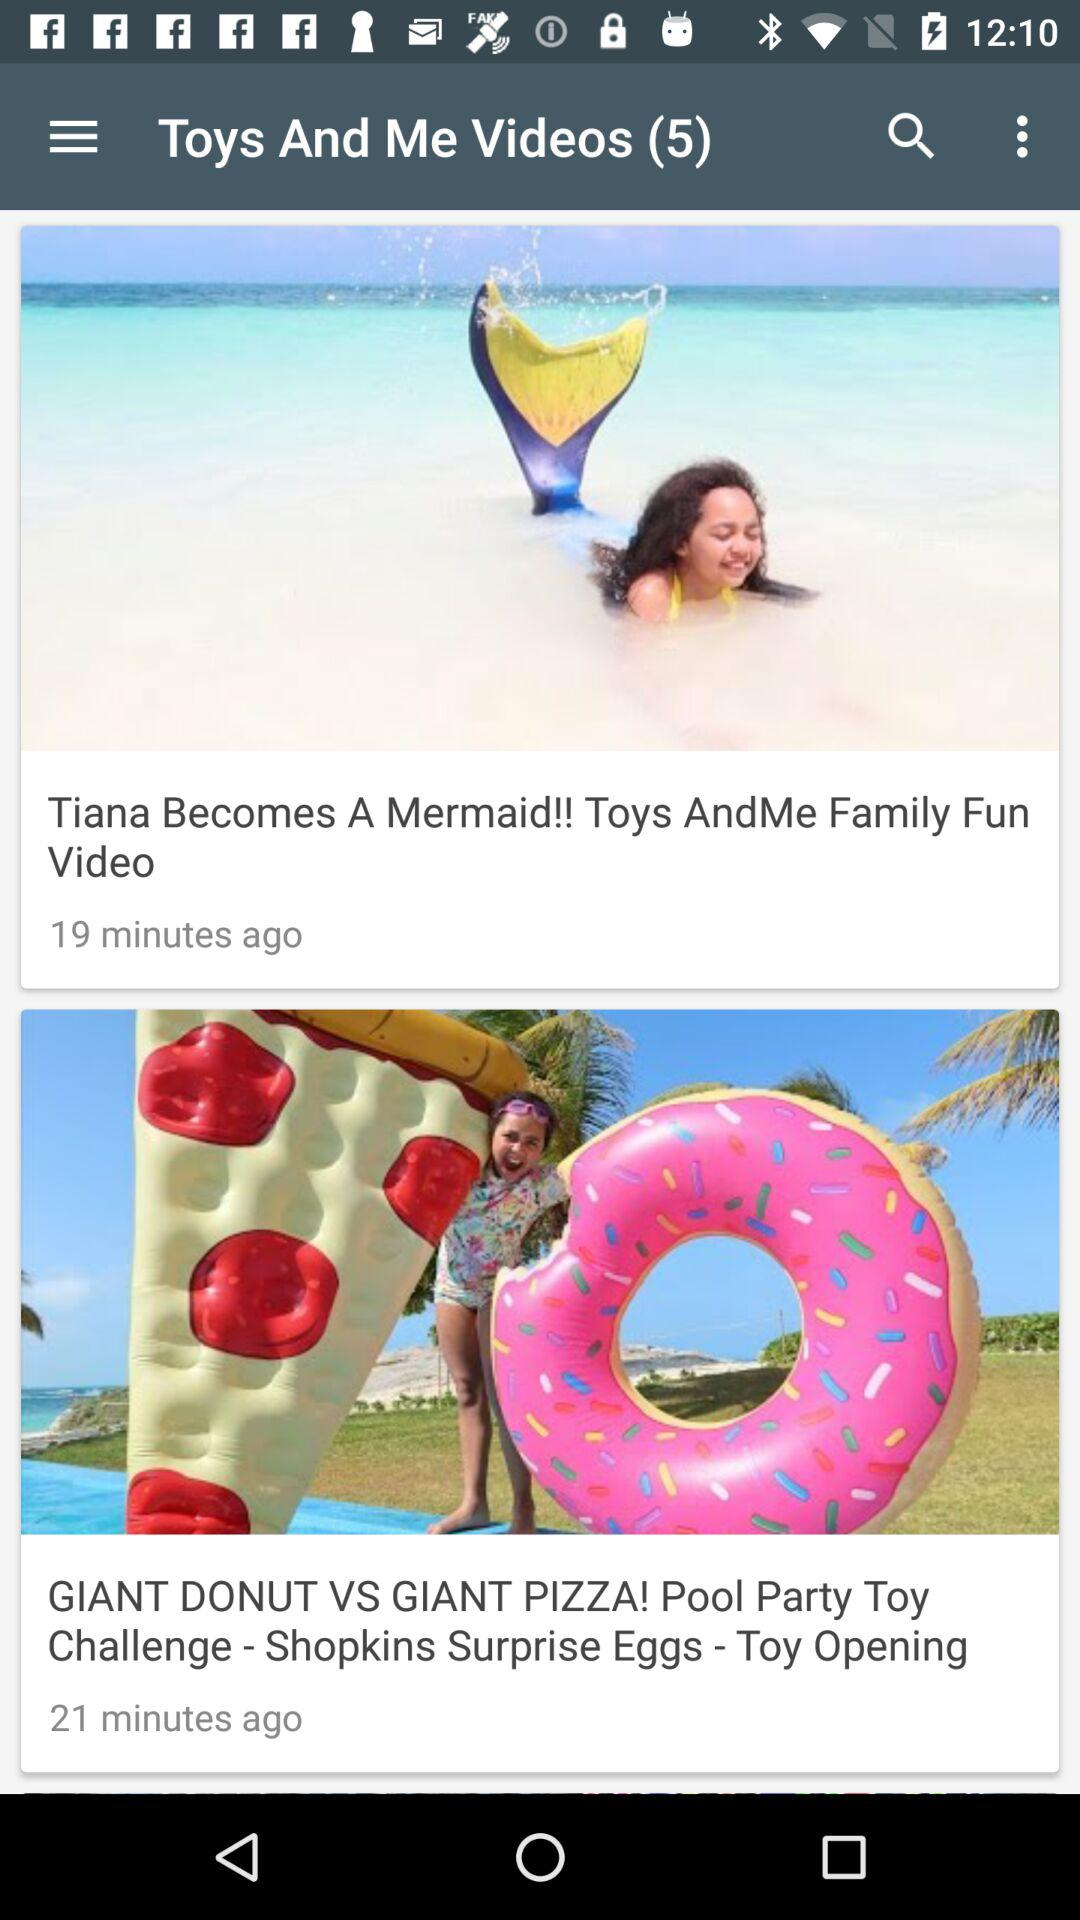Which video was uploaded 19 minutes ago? The video is "Tiana Becomes A Mermaid!! Toys AndMe Family Fun Video". 